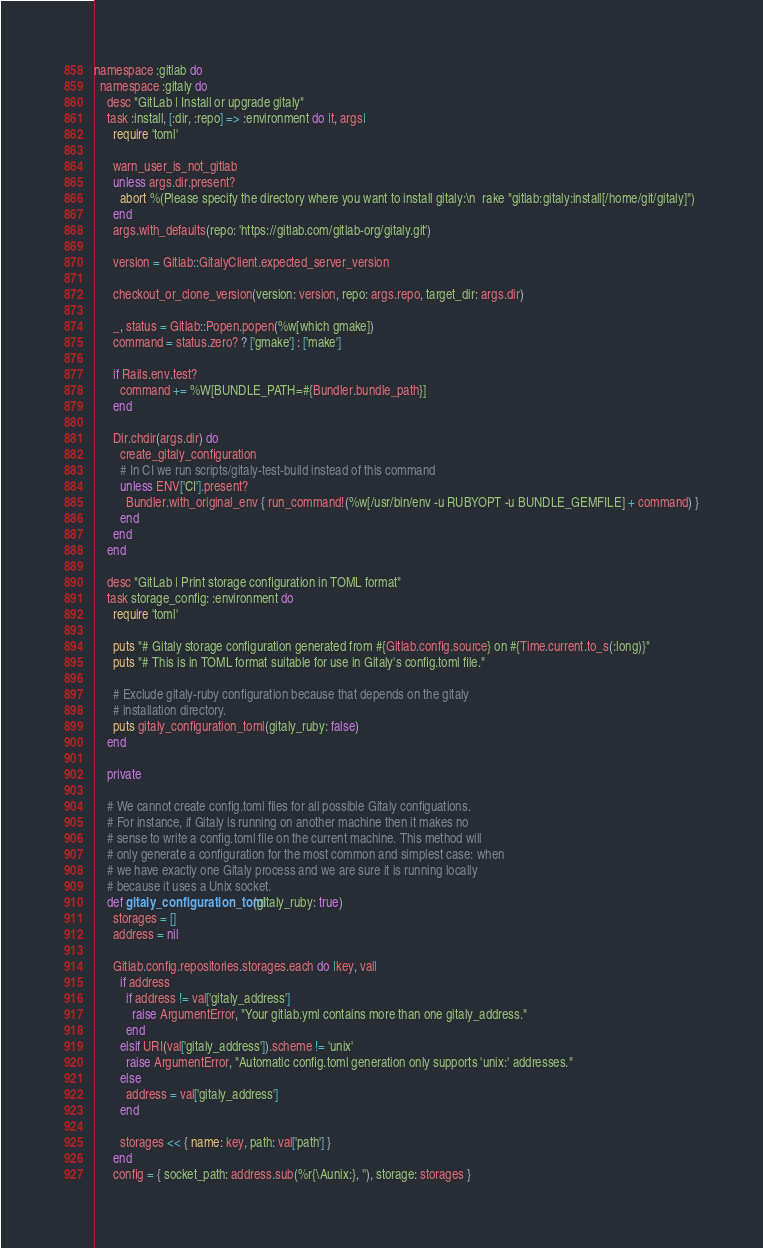<code> <loc_0><loc_0><loc_500><loc_500><_Ruby_>namespace :gitlab do
  namespace :gitaly do
    desc "GitLab | Install or upgrade gitaly"
    task :install, [:dir, :repo] => :environment do |t, args|
      require 'toml'

      warn_user_is_not_gitlab
      unless args.dir.present?
        abort %(Please specify the directory where you want to install gitaly:\n  rake "gitlab:gitaly:install[/home/git/gitaly]")
      end
      args.with_defaults(repo: 'https://gitlab.com/gitlab-org/gitaly.git')

      version = Gitlab::GitalyClient.expected_server_version

      checkout_or_clone_version(version: version, repo: args.repo, target_dir: args.dir)

      _, status = Gitlab::Popen.popen(%w[which gmake])
      command = status.zero? ? ['gmake'] : ['make']

      if Rails.env.test?
        command += %W[BUNDLE_PATH=#{Bundler.bundle_path}]
      end

      Dir.chdir(args.dir) do
        create_gitaly_configuration
        # In CI we run scripts/gitaly-test-build instead of this command
        unless ENV['CI'].present?
          Bundler.with_original_env { run_command!(%w[/usr/bin/env -u RUBYOPT -u BUNDLE_GEMFILE] + command) }
        end
      end
    end

    desc "GitLab | Print storage configuration in TOML format"
    task storage_config: :environment do
      require 'toml'

      puts "# Gitaly storage configuration generated from #{Gitlab.config.source} on #{Time.current.to_s(:long)}"
      puts "# This is in TOML format suitable for use in Gitaly's config.toml file."

      # Exclude gitaly-ruby configuration because that depends on the gitaly
      # installation directory.
      puts gitaly_configuration_toml(gitaly_ruby: false)
    end

    private

    # We cannot create config.toml files for all possible Gitaly configuations.
    # For instance, if Gitaly is running on another machine then it makes no
    # sense to write a config.toml file on the current machine. This method will
    # only generate a configuration for the most common and simplest case: when
    # we have exactly one Gitaly process and we are sure it is running locally
    # because it uses a Unix socket.
    def gitaly_configuration_toml(gitaly_ruby: true)
      storages = []
      address = nil

      Gitlab.config.repositories.storages.each do |key, val|
        if address
          if address != val['gitaly_address']
            raise ArgumentError, "Your gitlab.yml contains more than one gitaly_address."
          end
        elsif URI(val['gitaly_address']).scheme != 'unix'
          raise ArgumentError, "Automatic config.toml generation only supports 'unix:' addresses."
        else
          address = val['gitaly_address']
        end

        storages << { name: key, path: val['path'] }
      end
      config = { socket_path: address.sub(%r{\Aunix:}, ''), storage: storages }</code> 